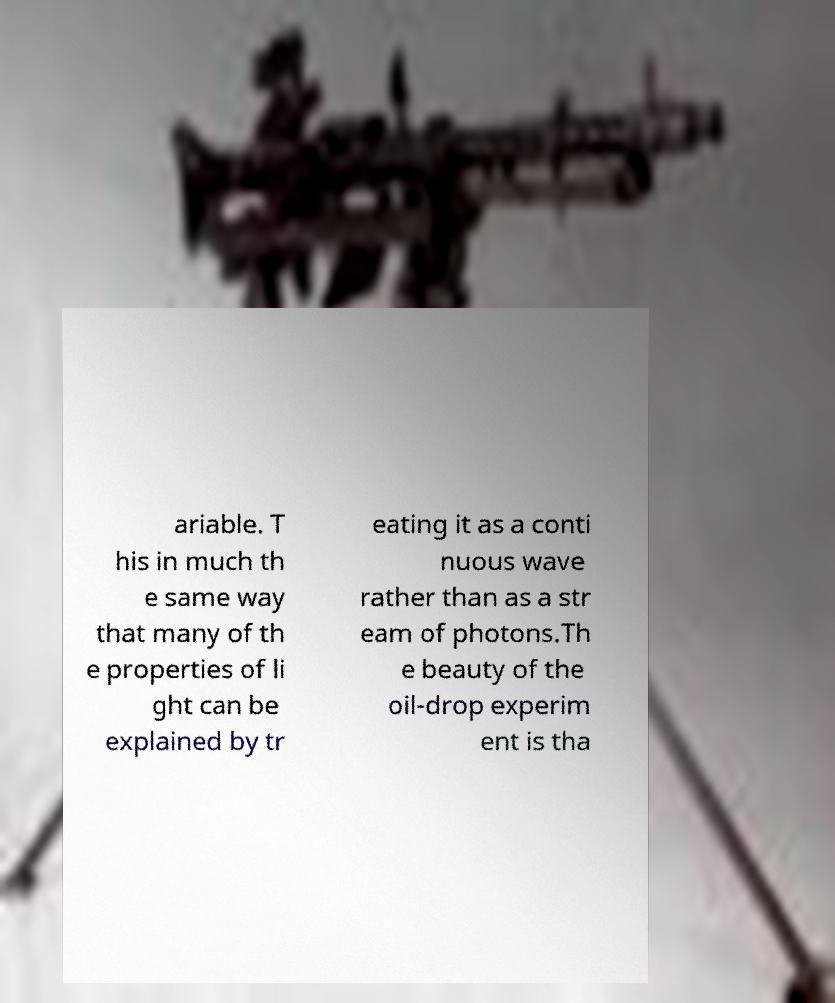Can you read and provide the text displayed in the image?This photo seems to have some interesting text. Can you extract and type it out for me? ariable. T his in much th e same way that many of th e properties of li ght can be explained by tr eating it as a conti nuous wave rather than as a str eam of photons.Th e beauty of the oil-drop experim ent is tha 